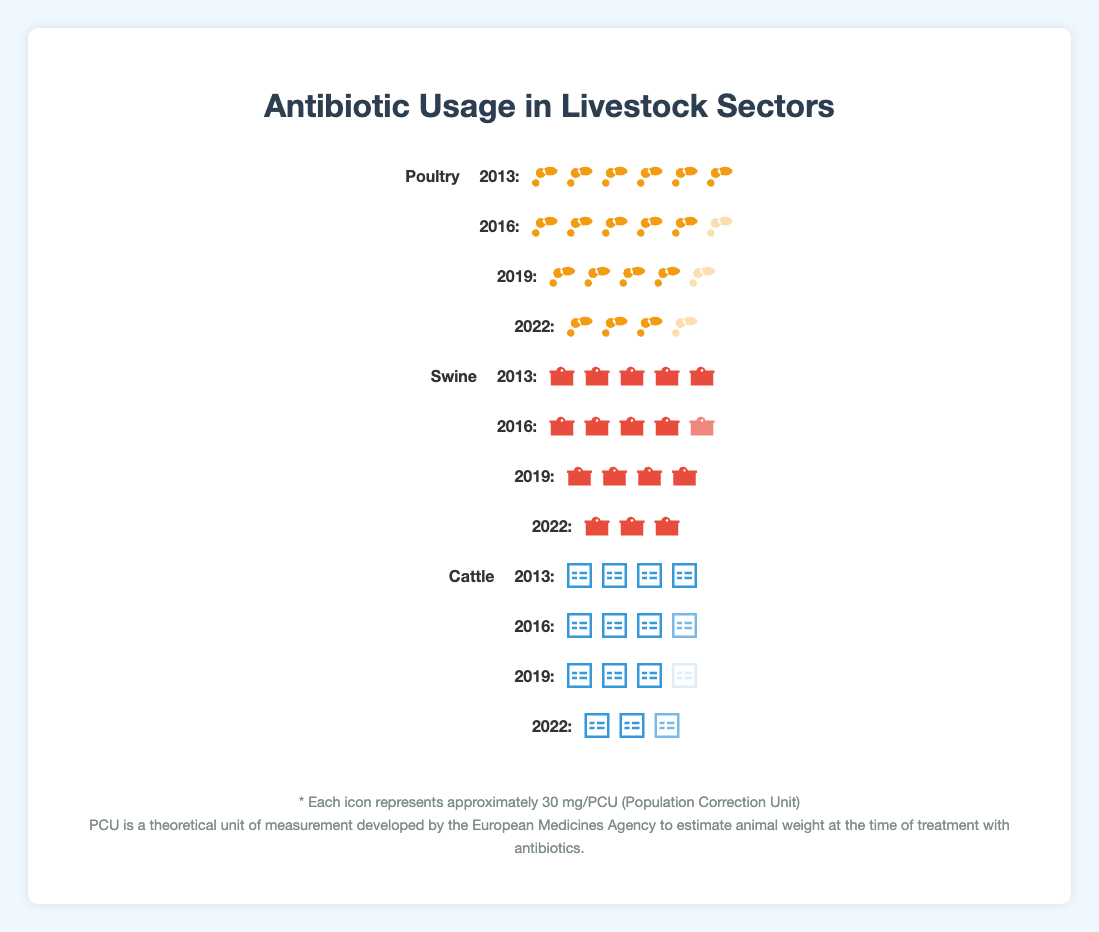What is the antibiotic usage in poultry for the year 2013? The figure shows six poultry icons with full opacity in 2013, where each icon represents 30 mg/PCU, hence 6 icons correspond to 6 * 30 mg/PCU = 180 mg/PCU.
Answer: 180 mg/PCU What is the trend of antibiotic usage in swine from 2013 to 2022? Observing the swine icons, the usage decreases over the years: 150 mg/PCU (2013), 140 mg/PCU (2016), 120 mg/PCU (2019), and 90 mg/PCU (2022).
Answer: Decreasing trend How does the antibiotic usage in cattle in 2022 compare to that in 2013? In 2022, there are three cattle icons (two full opacity and one two-thirds opacity) equating to 2.67 * 30 mg/PCU = 80 mg/PCU, compared to 4 icons in 2013 which equates to 120 mg/PCU, so it has decreased.
Answer: Decreased What is the cumulative antibiotic usage reduction in poultry from 2013 to 2022? The initial usage in 2013 is 180 mg/PCU, and it dropped to 100 mg/PCU in 2022. The reduction is 180 mg/PCU - 100 mg/PCU = 80 mg/PCU.
Answer: 80 mg/PCU Which livestock sector has the smallest reduction in antibiotic usage from 2013 to 2022? The reductions are: Poultry 80 mg/PCU (180 to 100), Swine 60 mg/PCU (150 to 90), and Cattle 40 mg/PCU (120 to 80). Hence, cattle has the smallest reduction.
Answer: Cattle What is the average antibiotic usage in cattle from 2013 to 2022? Sum the values for cattle: 120 + 110 + 95 + 80 = 405 mg/PCU. Dividing by the 4 years: 405 mg/PCU / 4 = 101.25 mg/PCU.
Answer: 101.25 mg/PCU In which year did swine have the highest antibiotic usage? By examining the swine icons, 2013 has the highest number of swine icons with five full opacity icons representing 150 mg/PCU.
Answer: 2013 What is the total antibiotic usage in all sectors in 2022? Add the values: Poultry 100 mg/PCU, Swine 90 mg/PCU, and Cattle 80 mg/PCU, yielding 100 + 90 + 80 = 270 mg/PCU.
Answer: 270 mg/PCU 